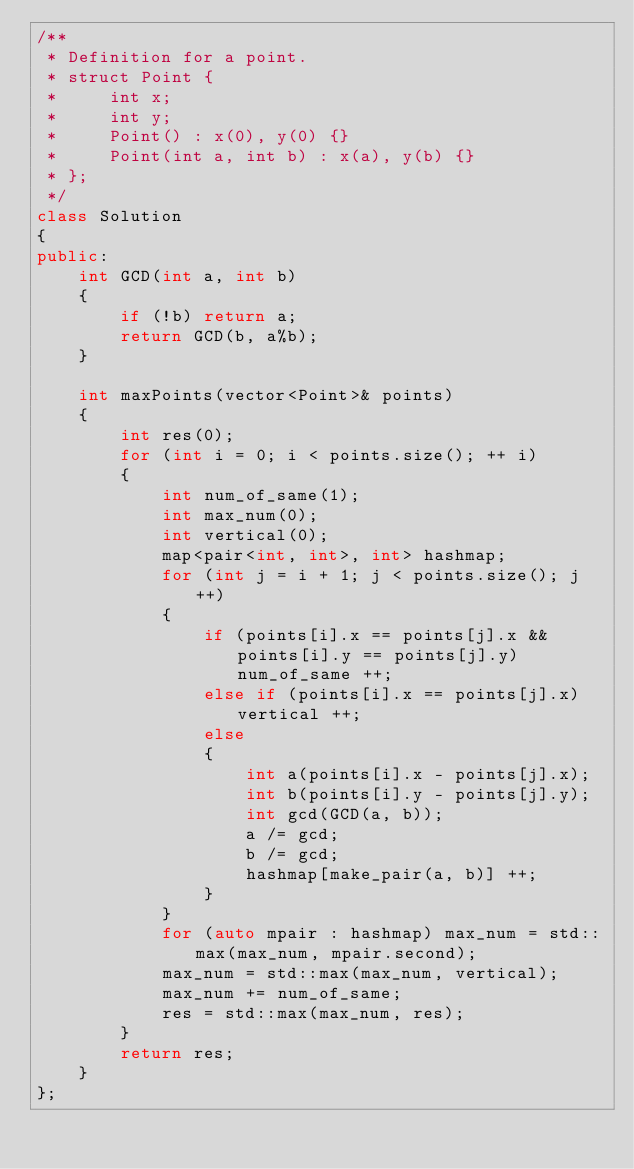Convert code to text. <code><loc_0><loc_0><loc_500><loc_500><_C++_>/**
 * Definition for a point.
 * struct Point {
 *     int x;
 *     int y;
 *     Point() : x(0), y(0) {}
 *     Point(int a, int b) : x(a), y(b) {}
 * };
 */
class Solution 
{
public:
    int GCD(int a, int b)
    {
        if (!b) return a;
        return GCD(b, a%b);
    }
    
    int maxPoints(vector<Point>& points) 
    {
        int res(0);
        for (int i = 0; i < points.size(); ++ i)
        {
            int num_of_same(1);
            int max_num(0);
            int vertical(0);
            map<pair<int, int>, int> hashmap;
            for (int j = i + 1; j < points.size(); j ++)
            {
                if (points[i].x == points[j].x && points[i].y == points[j].y) num_of_same ++;
                else if (points[i].x == points[j].x) vertical ++;
                else 
                {
                    int a(points[i].x - points[j].x);
                    int b(points[i].y - points[j].y);
                    int gcd(GCD(a, b));
                    a /= gcd;
                    b /= gcd;
                    hashmap[make_pair(a, b)] ++;
                }
            }
            for (auto mpair : hashmap) max_num = std::max(max_num, mpair.second);
            max_num = std::max(max_num, vertical);
            max_num += num_of_same;
            res = std::max(max_num, res);
        }
        return res;
    }
};</code> 